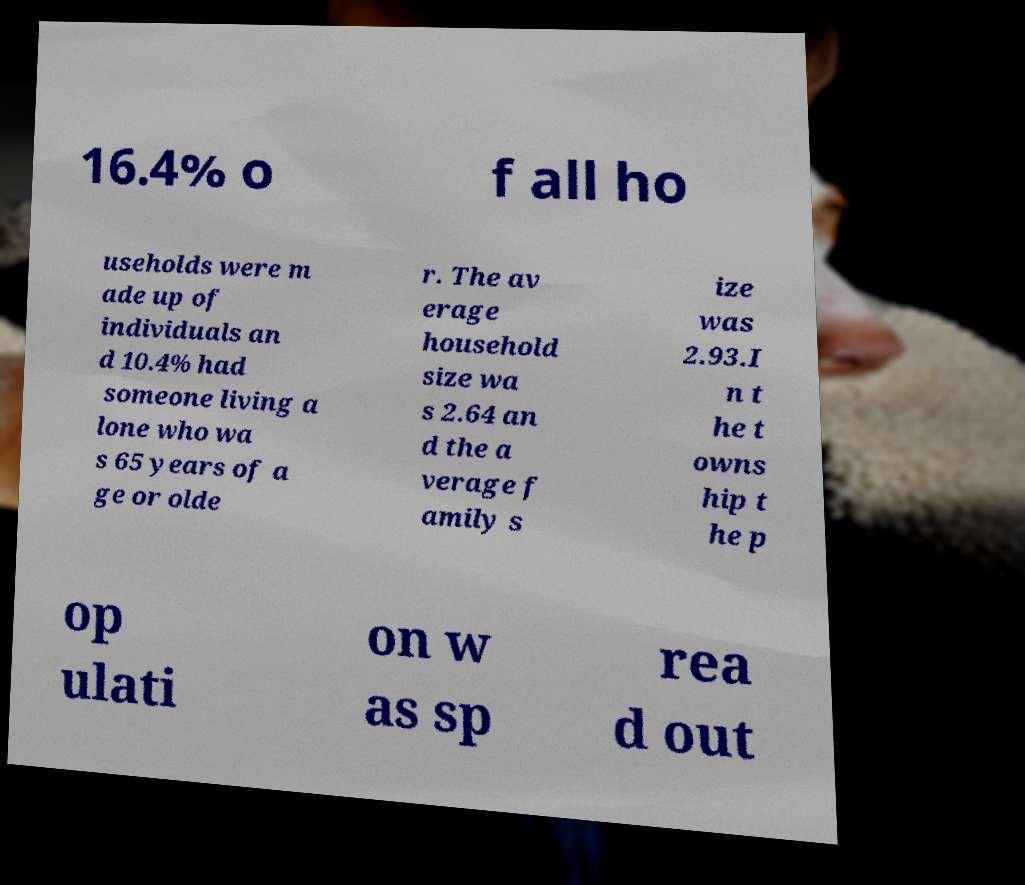Can you accurately transcribe the text from the provided image for me? 16.4% o f all ho useholds were m ade up of individuals an d 10.4% had someone living a lone who wa s 65 years of a ge or olde r. The av erage household size wa s 2.64 an d the a verage f amily s ize was 2.93.I n t he t owns hip t he p op ulati on w as sp rea d out 